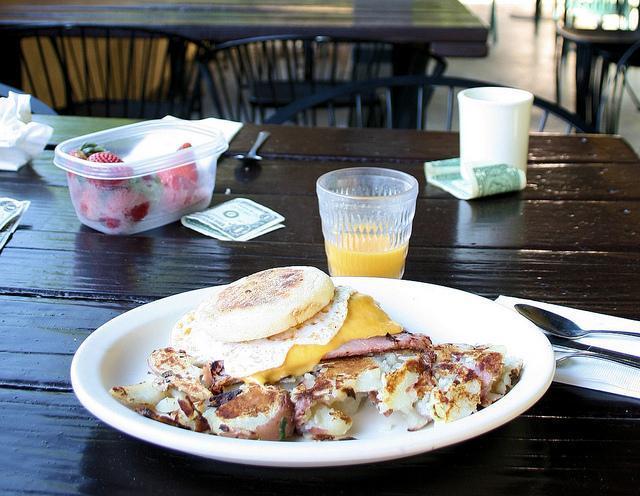How many dining tables can you see?
Give a very brief answer. 2. How many cups are visible?
Give a very brief answer. 2. How many chairs are in the photo?
Give a very brief answer. 3. How many sandwiches are in the picture?
Give a very brief answer. 2. How many bananas are shown?
Give a very brief answer. 0. 